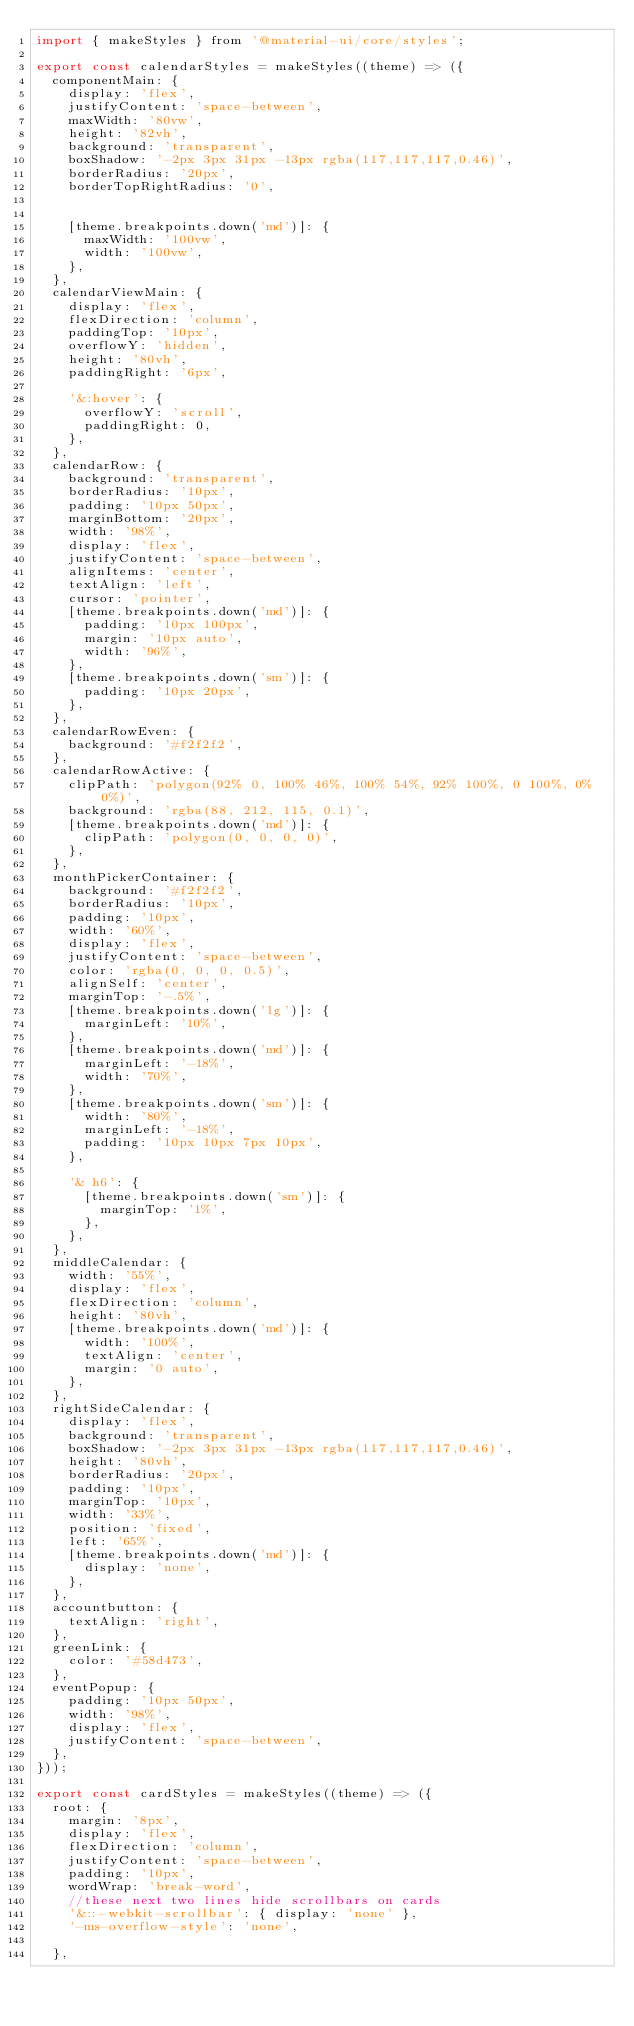Convert code to text. <code><loc_0><loc_0><loc_500><loc_500><_JavaScript_>import { makeStyles } from '@material-ui/core/styles';

export const calendarStyles = makeStyles((theme) => ({
  componentMain: {
    display: 'flex',
    justifyContent: 'space-between',
    maxWidth: '80vw',
    height: '82vh',
    background: 'transparent',
    boxShadow: '-2px 3px 31px -13px rgba(117,117,117,0.46)',
    borderRadius: '20px',
    borderTopRightRadius: '0',
   

    [theme.breakpoints.down('md')]: {
      maxWidth: '100vw',
      width: '100vw',
    },
  },
  calendarViewMain: {
    display: 'flex',
    flexDirection: 'column',
    paddingTop: '10px',
    overflowY: 'hidden',
    height: '80vh',
    paddingRight: '6px',

    '&:hover': {
      overflowY: 'scroll',
      paddingRight: 0,
    },
  },
  calendarRow: {
    background: 'transparent',
    borderRadius: '10px',
    padding: '10px 50px',
    marginBottom: '20px',
    width: '98%',
    display: 'flex',
    justifyContent: 'space-between',
    alignItems: 'center',
    textAlign: 'left',
    cursor: 'pointer',
    [theme.breakpoints.down('md')]: {
      padding: '10px 100px',
      margin: '10px auto',
      width: '96%',
    },
    [theme.breakpoints.down('sm')]: {
      padding: '10px 20px',
    },
  },
  calendarRowEven: {
    background: '#f2f2f2',
  },
  calendarRowActive: {
    clipPath: 'polygon(92% 0, 100% 46%, 100% 54%, 92% 100%, 0 100%, 0% 0%)',
    background: 'rgba(88, 212, 115, 0.1)',
    [theme.breakpoints.down('md')]: {
      clipPath: 'polygon(0, 0, 0, 0)',
    },
  },
  monthPickerContainer: {
    background: '#f2f2f2',
    borderRadius: '10px',
    padding: '10px',
    width: '60%',
    display: 'flex',
    justifyContent: 'space-between',
    color: 'rgba(0, 0, 0, 0.5)',
    alignSelf: 'center',
    marginTop: '-.5%',
    [theme.breakpoints.down('lg')]: {
      marginLeft: '10%',
    },
    [theme.breakpoints.down('md')]: {
      marginLeft: '-18%',
      width: '70%',
    },
    [theme.breakpoints.down('sm')]: {
      width: '80%',
      marginLeft: '-18%',
      padding: '10px 10px 7px 10px',
    },

    '& h6': {
      [theme.breakpoints.down('sm')]: {
        marginTop: '1%',
      },
    },
  },
  middleCalendar: {
    width: '55%',
    display: 'flex',
    flexDirection: 'column',
    height: '80vh',
    [theme.breakpoints.down('md')]: {
      width: '100%',
      textAlign: 'center',
      margin: '0 auto',
    },
  },
  rightSideCalendar: {
    display: 'flex',
    background: 'transparent',
    boxShadow: '-2px 3px 31px -13px rgba(117,117,117,0.46)',
    height: '80vh',
    borderRadius: '20px',
    padding: '10px',
    marginTop: '10px',
    width: '33%',
    position: 'fixed',
    left: '65%',
    [theme.breakpoints.down('md')]: {
      display: 'none',
    },
  },
  accountbutton: {
    textAlign: 'right',
  },
  greenLink: {
    color: '#58d473',
  },
  eventPopup: {
    padding: '10px 50px',
    width: '98%',
    display: 'flex',
    justifyContent: 'space-between',
  },
}));

export const cardStyles = makeStyles((theme) => ({
  root: {
    margin: '8px',
    display: 'flex',
    flexDirection: 'column',
    justifyContent: 'space-between',
    padding: '10px',
    wordWrap: 'break-word',
    //these next two lines hide scrollbars on cards
    '&::-webkit-scrollbar': { display: 'none' },
    '-ms-overflow-style': 'none',

  },</code> 